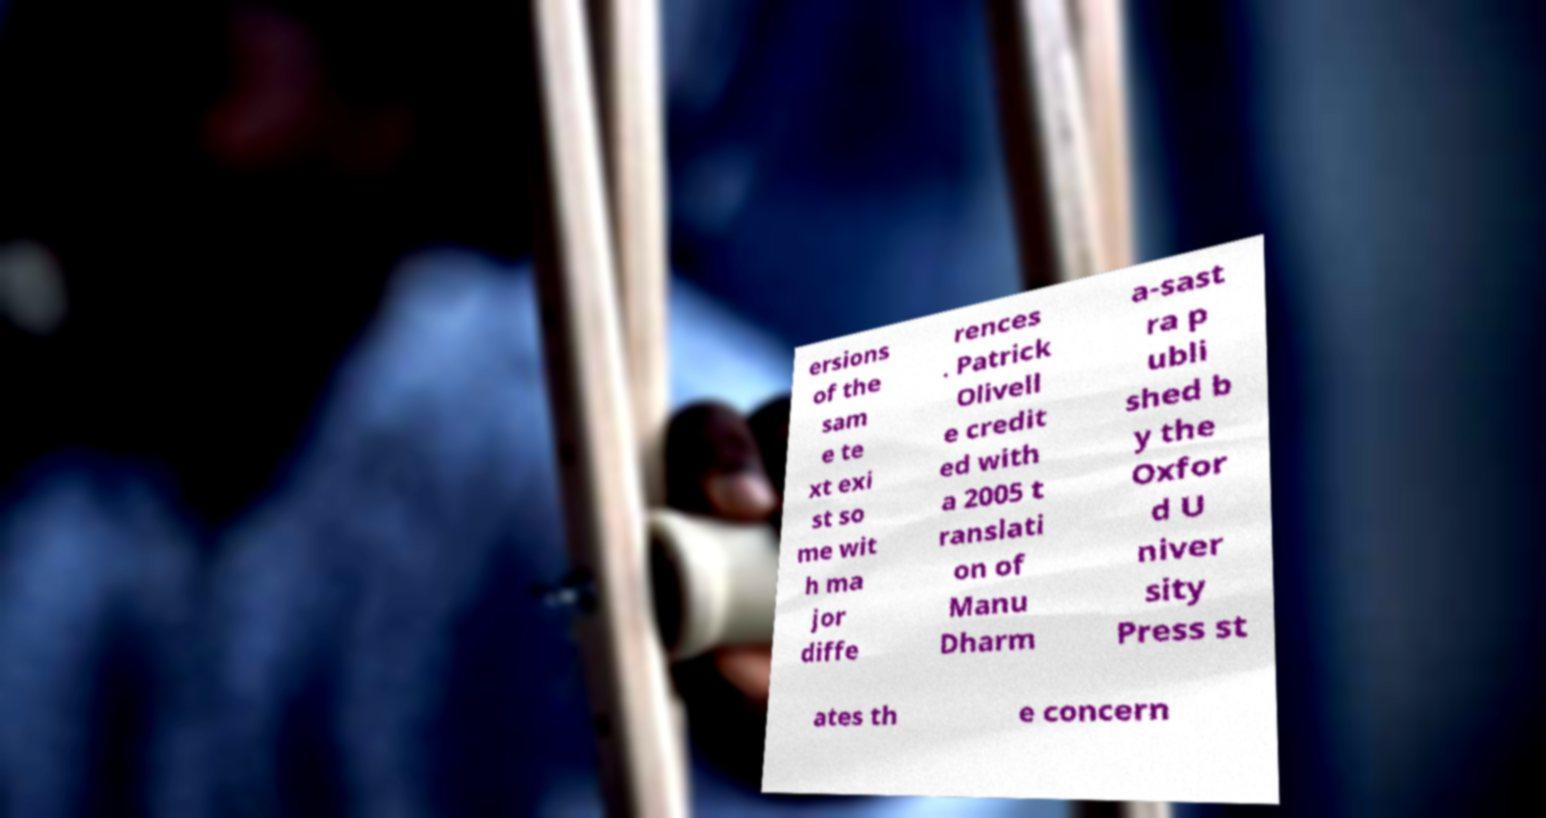Could you assist in decoding the text presented in this image and type it out clearly? ersions of the sam e te xt exi st so me wit h ma jor diffe rences . Patrick Olivell e credit ed with a 2005 t ranslati on of Manu Dharm a-sast ra p ubli shed b y the Oxfor d U niver sity Press st ates th e concern 